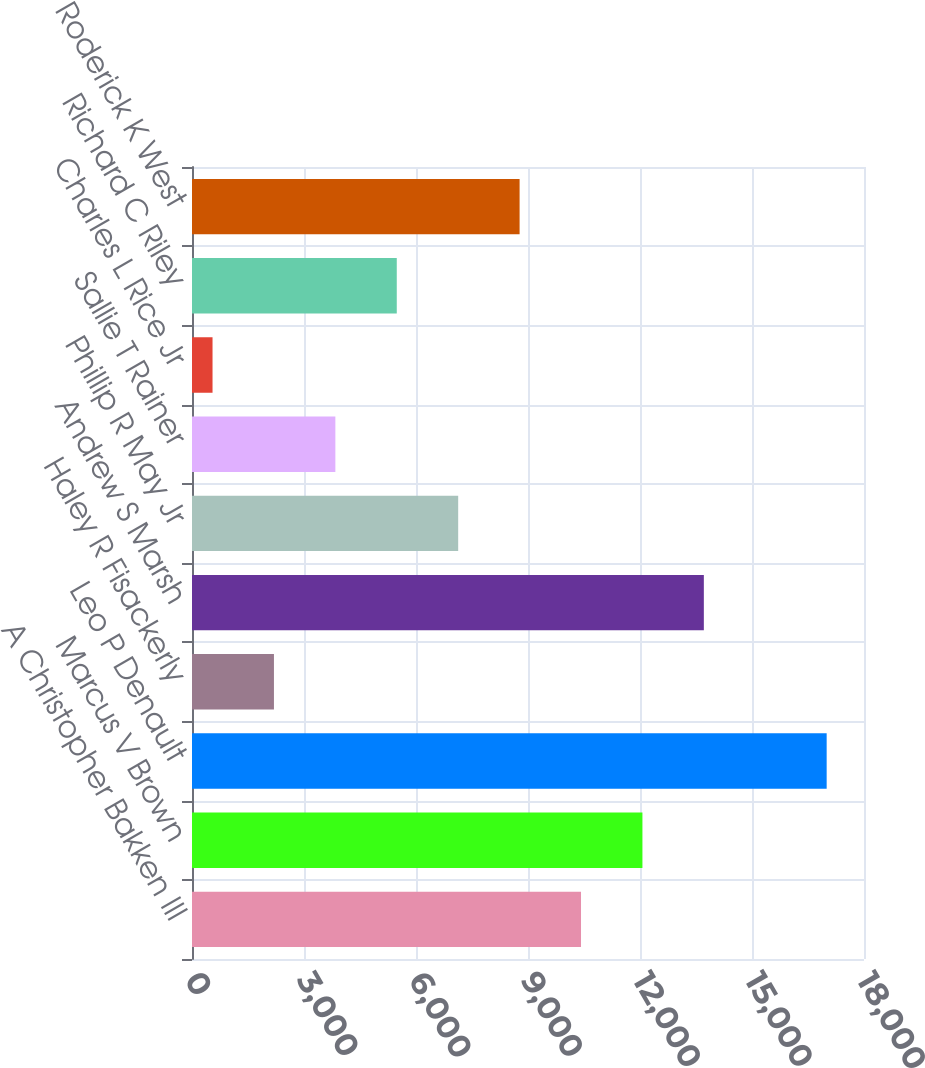Convert chart. <chart><loc_0><loc_0><loc_500><loc_500><bar_chart><fcel>A Christopher Bakken III<fcel>Marcus V Brown<fcel>Leo P Denault<fcel>Haley R Fisackerly<fcel>Andrew S Marsh<fcel>Phillip R May Jr<fcel>Sallie T Rainer<fcel>Charles L Rice Jr<fcel>Richard C Riley<fcel>Roderick K West<nl><fcel>10420<fcel>12065<fcel>17000<fcel>2195<fcel>13710<fcel>7130<fcel>3840<fcel>550<fcel>5485<fcel>8775<nl></chart> 